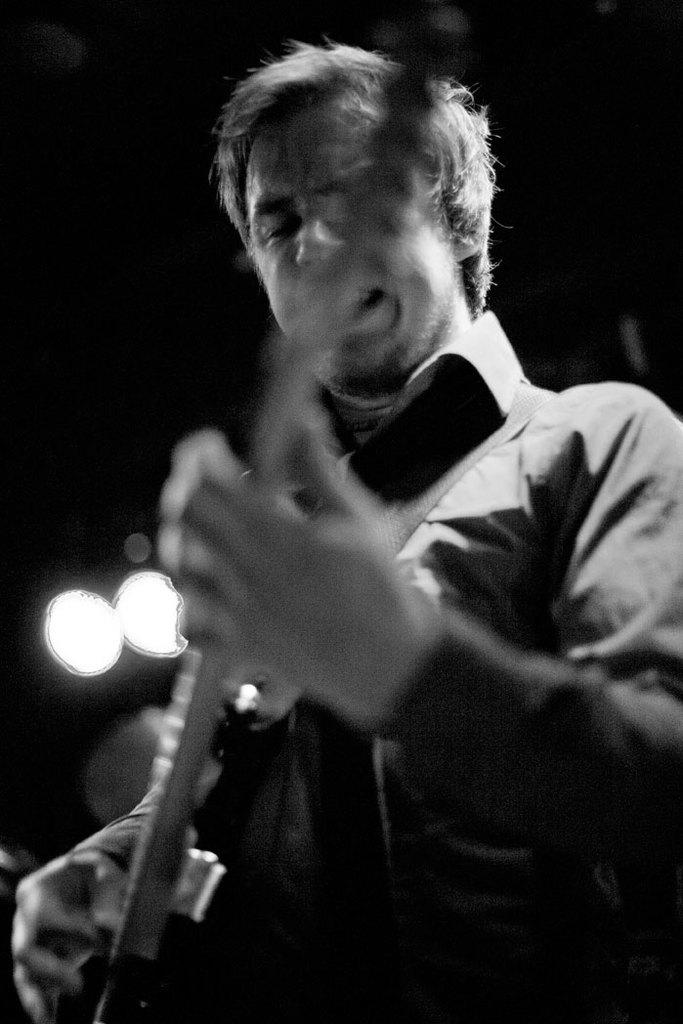What is the person in the image doing? The person is playing a guitar and singing. What instrument is the person playing in the image? The person is playing a guitar. What can be seen in the background of the image? There are lights visible in the background of the image. What type of mint is being used to flavor the eggnog in the image? There is no eggnog or mint present in the image; it features a person playing a guitar and singing. 